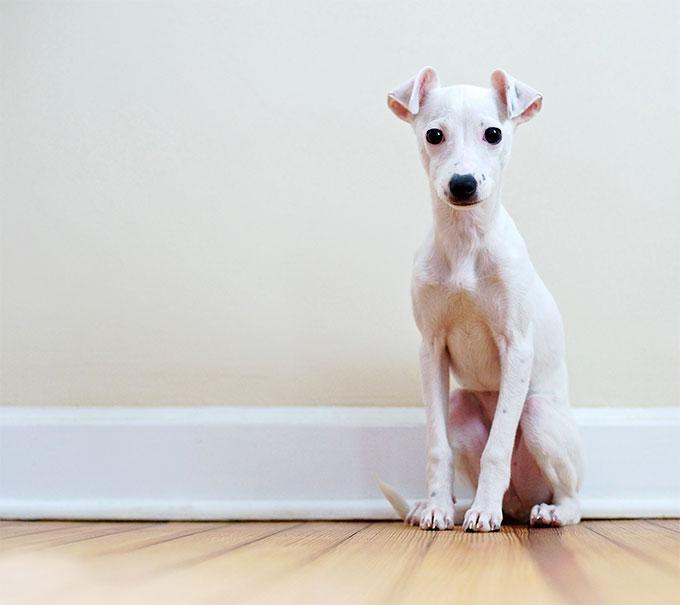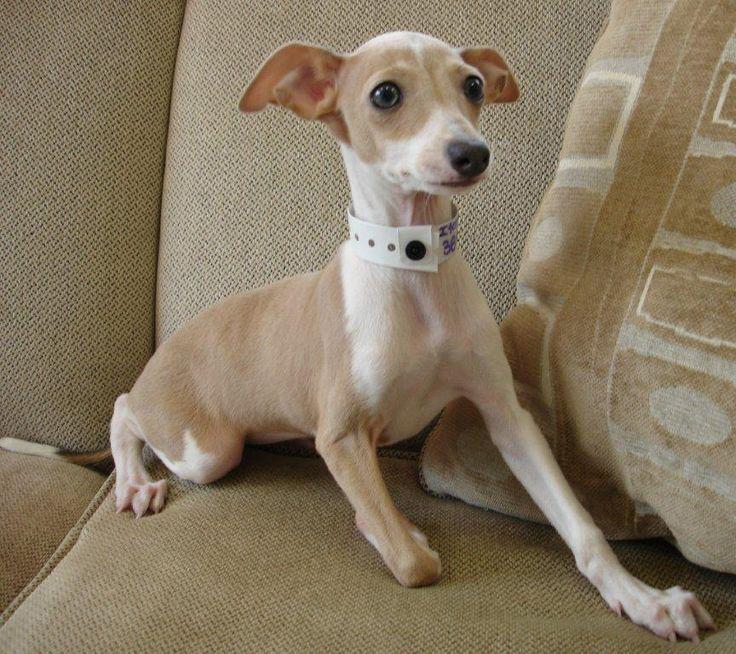The first image is the image on the left, the second image is the image on the right. Examine the images to the left and right. Is the description "In one image, a dog's very long tongue is outside of its mouth and at least one ear is pulled towards the back of its head." accurate? Answer yes or no. No. The first image is the image on the left, the second image is the image on the right. Considering the images on both sides, is "The dog in one of the images is sitting on a soft surface." valid? Answer yes or no. Yes. 